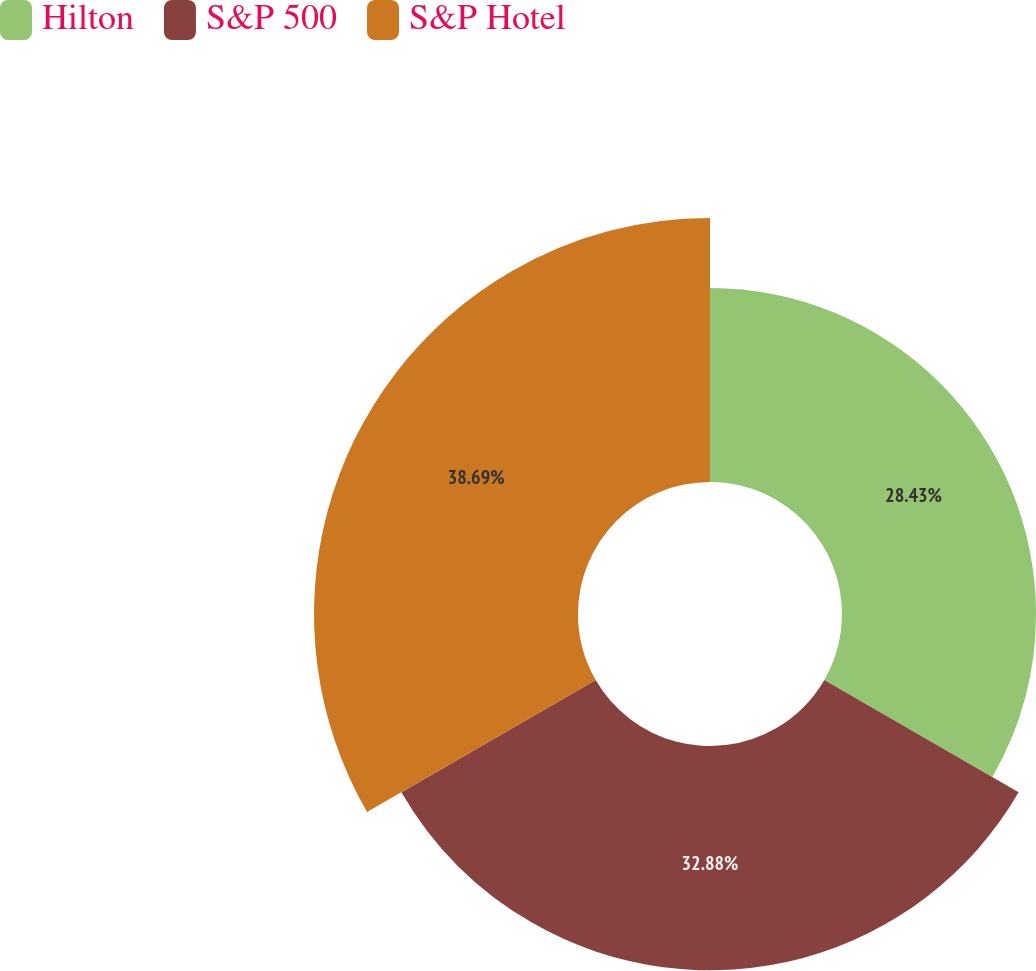<chart> <loc_0><loc_0><loc_500><loc_500><pie_chart><fcel>Hilton<fcel>S&P 500<fcel>S&P Hotel<nl><fcel>28.43%<fcel>32.88%<fcel>38.69%<nl></chart> 